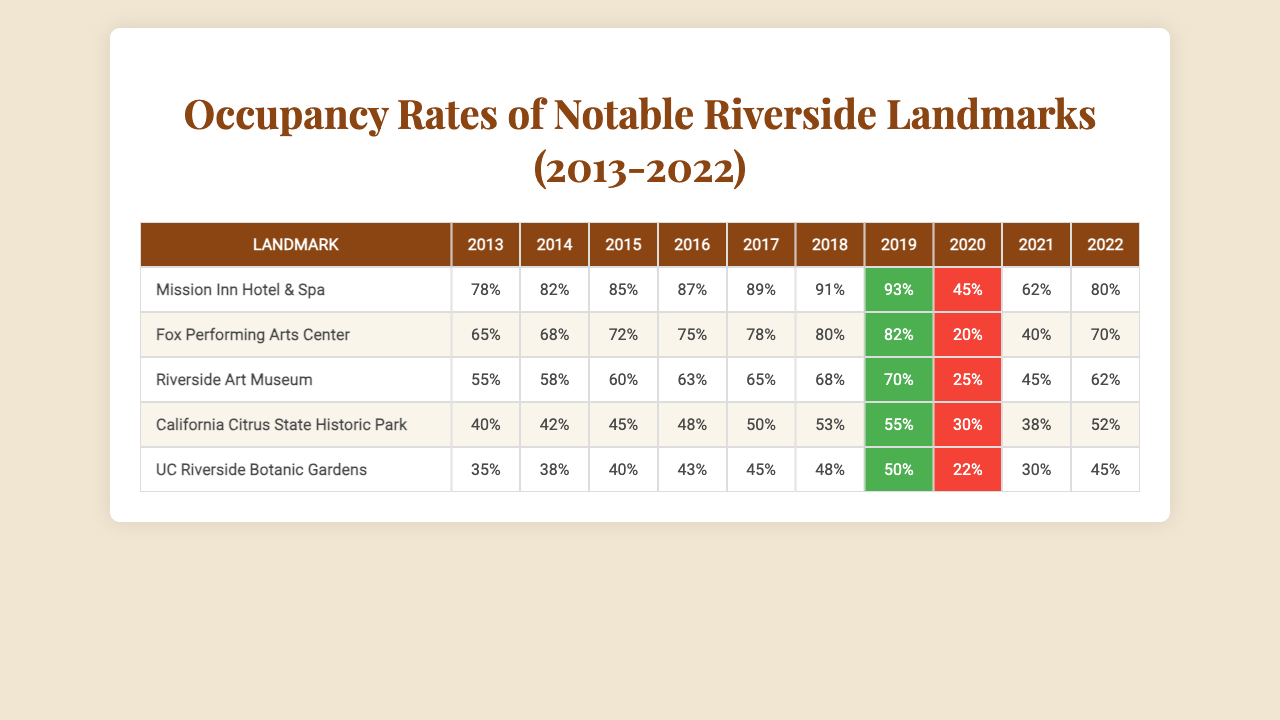What was the occupancy rate of the Mission Inn Hotel & Spa in 2019? Referring to the row for the Mission Inn Hotel & Spa and locating the value for the year 2019, we see that the occupancy rate is 93%.
Answer: 93% Which landmark had the lowest occupancy rate in 2020? By inspecting the occupancy rates for all landmarks in 2020, we find the values are: Mission Inn Hotel & Spa (45%), Fox Performing Arts Center (20%), Riverside Art Museum (25%), California Citrus State Historic Park (30%), and UC Riverside Botanic Gardens (22%). The lowest is Fox Performing Arts Center with 20%.
Answer: Fox Performing Arts Center What was the average occupancy rate for the Riverside Art Museum over the decade? To find the average, we sum the occupancy rates for the Riverside Art Museum from 2013 to 2022, which are: 55, 58, 60, 63, 65, 68, 70, 25, 45, and 62. This totals  55 + 58 + 60 + 63 + 65 + 68 + 70 + 25 + 45 + 62 =  615. Dividing by the total number of years (10) gives us an average of 61.5.
Answer: 61.5 Did the occupancy rate for California Citrus State Historic Park ever exceed 50% between 2013 and 2022? Looking at the data for California Citrus State Historic Park, the occupancy rates are 40%, 42%, 45%, 48%, 50%, 53%, 55%, 30%, 38%, and 52%. The highest value is 55%, which exceeds 50%. Therefore, the statement is true.
Answer: Yes What is the difference in occupancy rate between the highest and lowest years for the UC Riverside Botanic Gardens? The highest occupancy rate is in 2019 at 50%, and the lowest is in 2020 at 22%. Calculating the difference, we subtract 22 from 50, resulting in 50 - 22 = 28.
Answer: 28 What was the trend in occupancy rates for the Mission Inn Hotel & Spa from 2013 to 2022? By reviewing the occupancy rates for the Mission Inn Hotel & Spa over the years: 78%, 82%, 85%, 87%, 89%, 91%, 93%, then a drop to 45% in 2020, followed by a recovery to 80% in 2022, we can see a general upward trend until 2019, followed by a significant drop in 2020, concluding with a rebound to 80% in 2022.
Answer: Upward trend, drop in 2020, recovery in 2022 Which two landmarks had their highest occupancy rates in the same year, 2017? In 2017, the highest occupancy rates are: Mission Inn Hotel & Spa (89%) and Fox Performing Arts Center (78%). Both landmarks reached their peak occupancy rate in that particular year.
Answer: Mission Inn Hotel & Spa and Fox Performing Arts Center 